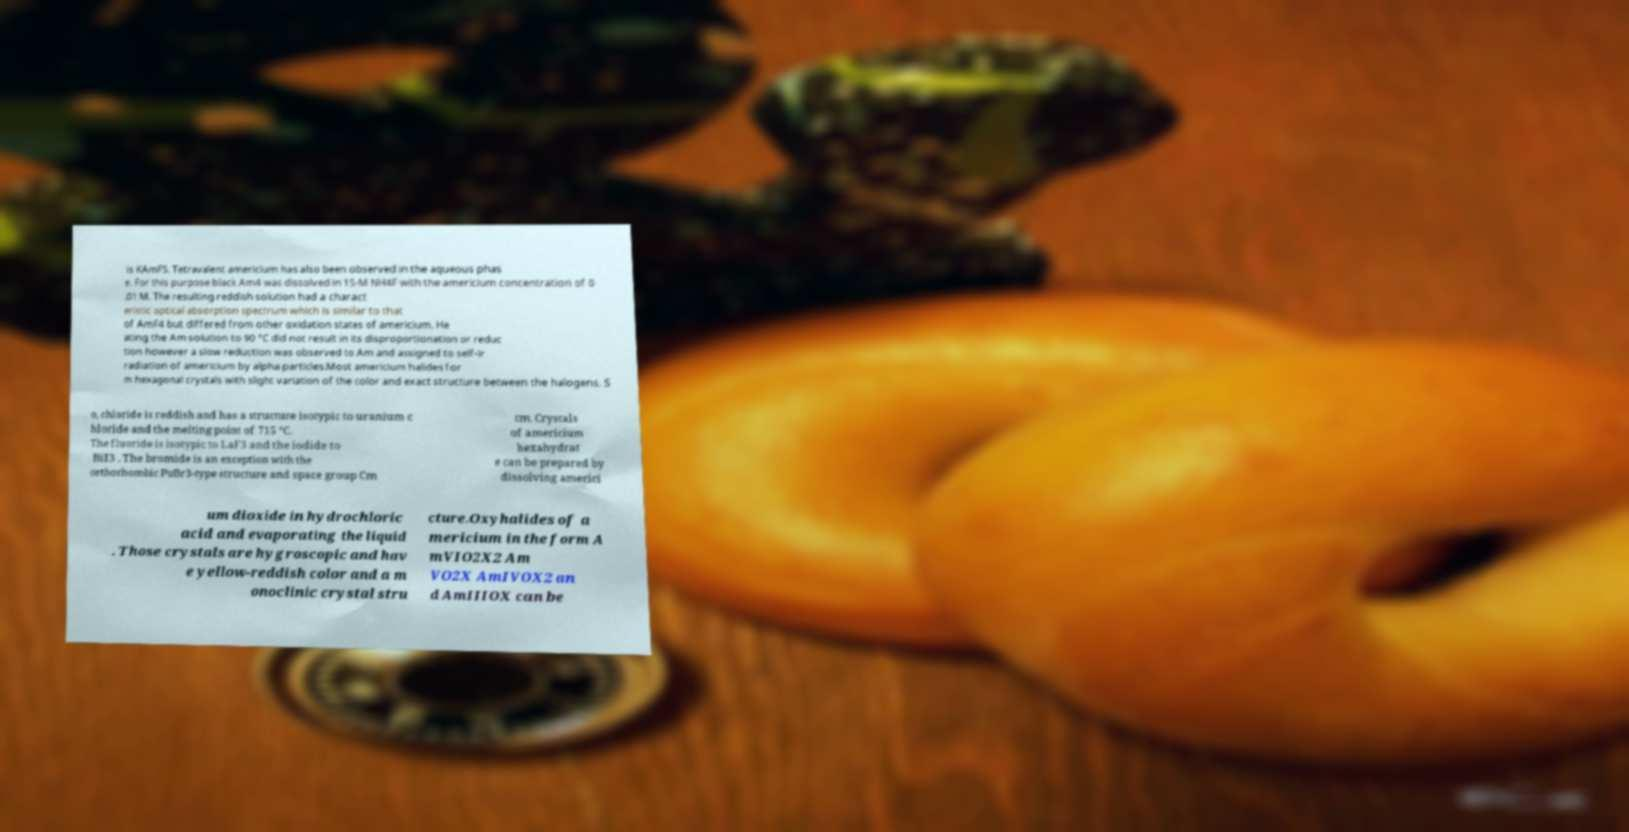Could you assist in decoding the text presented in this image and type it out clearly? is KAmF5. Tetravalent americium has also been observed in the aqueous phas e. For this purpose black Am4 was dissolved in 15-M NH4F with the americium concentration of 0 .01 M. The resulting reddish solution had a charact eristic optical absorption spectrum which is similar to that of AmF4 but differed from other oxidation states of americium. He ating the Am solution to 90 °C did not result in its disproportionation or reduc tion however a slow reduction was observed to Am and assigned to self-ir radiation of americium by alpha particles.Most americium halides for m hexagonal crystals with slight variation of the color and exact structure between the halogens. S o, chloride is reddish and has a structure isotypic to uranium c hloride and the melting point of 715 °C. The fluoride is isotypic to LaF3 and the iodide to BiI3 . The bromide is an exception with the orthorhombic PuBr3-type structure and space group Cm cm. Crystals of americium hexahydrat e can be prepared by dissolving americi um dioxide in hydrochloric acid and evaporating the liquid . Those crystals are hygroscopic and hav e yellow-reddish color and a m onoclinic crystal stru cture.Oxyhalides of a mericium in the form A mVIO2X2 Am VO2X AmIVOX2 an d AmIIIOX can be 